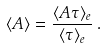Convert formula to latex. <formula><loc_0><loc_0><loc_500><loc_500>\langle A \rangle = \frac { \langle A \tau \rangle _ { e } } { \langle \tau \rangle _ { e } } \, .</formula> 